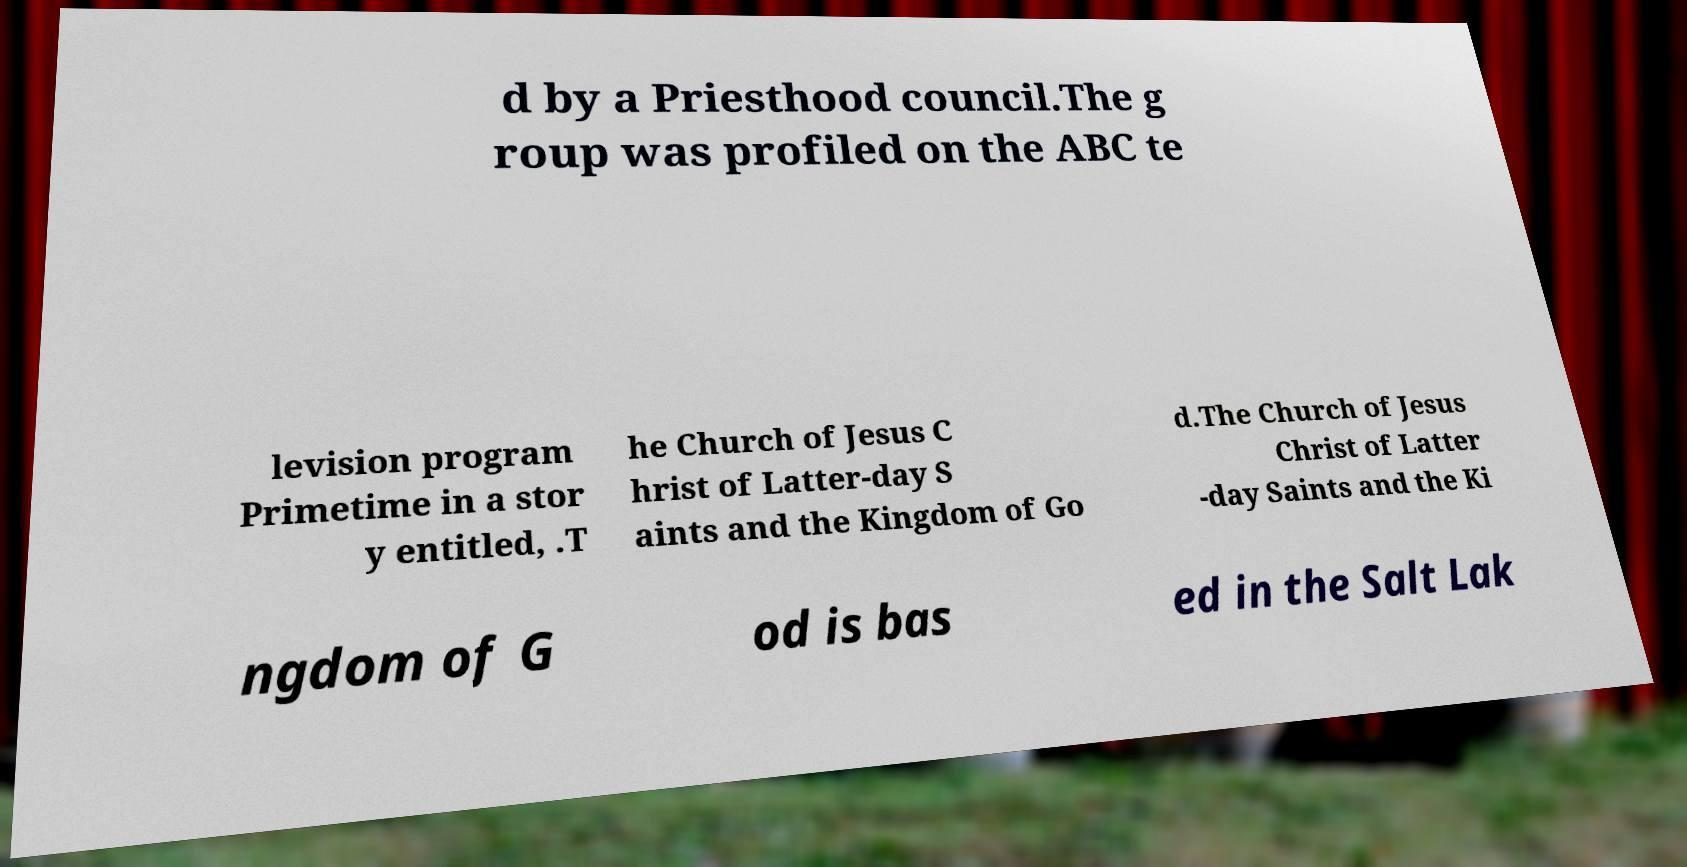Could you assist in decoding the text presented in this image and type it out clearly? d by a Priesthood council.The g roup was profiled on the ABC te levision program Primetime in a stor y entitled, .T he Church of Jesus C hrist of Latter-day S aints and the Kingdom of Go d.The Church of Jesus Christ of Latter -day Saints and the Ki ngdom of G od is bas ed in the Salt Lak 